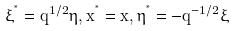Convert formula to latex. <formula><loc_0><loc_0><loc_500><loc_500>\xi ^ { ^ { * } } = q ^ { 1 / 2 } \eta , x ^ { ^ { * } } = x , \eta ^ { ^ { * } } = - q ^ { - 1 / 2 } \xi</formula> 